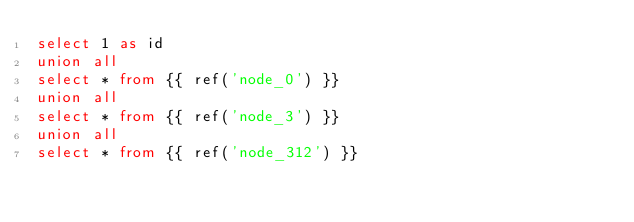Convert code to text. <code><loc_0><loc_0><loc_500><loc_500><_SQL_>select 1 as id
union all
select * from {{ ref('node_0') }}
union all
select * from {{ ref('node_3') }}
union all
select * from {{ ref('node_312') }}
</code> 